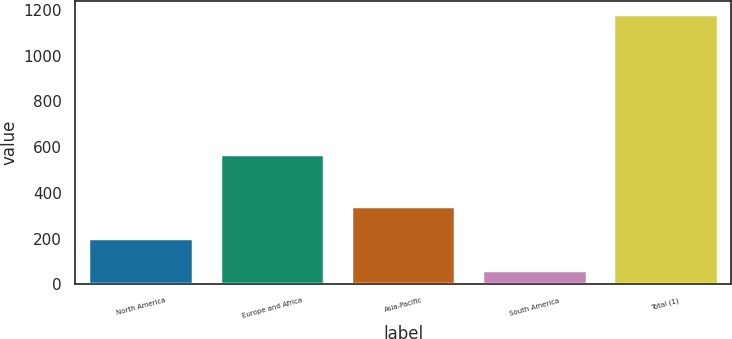<chart> <loc_0><loc_0><loc_500><loc_500><bar_chart><fcel>North America<fcel>Europe and Africa<fcel>Asia-Pacific<fcel>South America<fcel>Total (1)<nl><fcel>203<fcel>572<fcel>344<fcel>63<fcel>1182<nl></chart> 